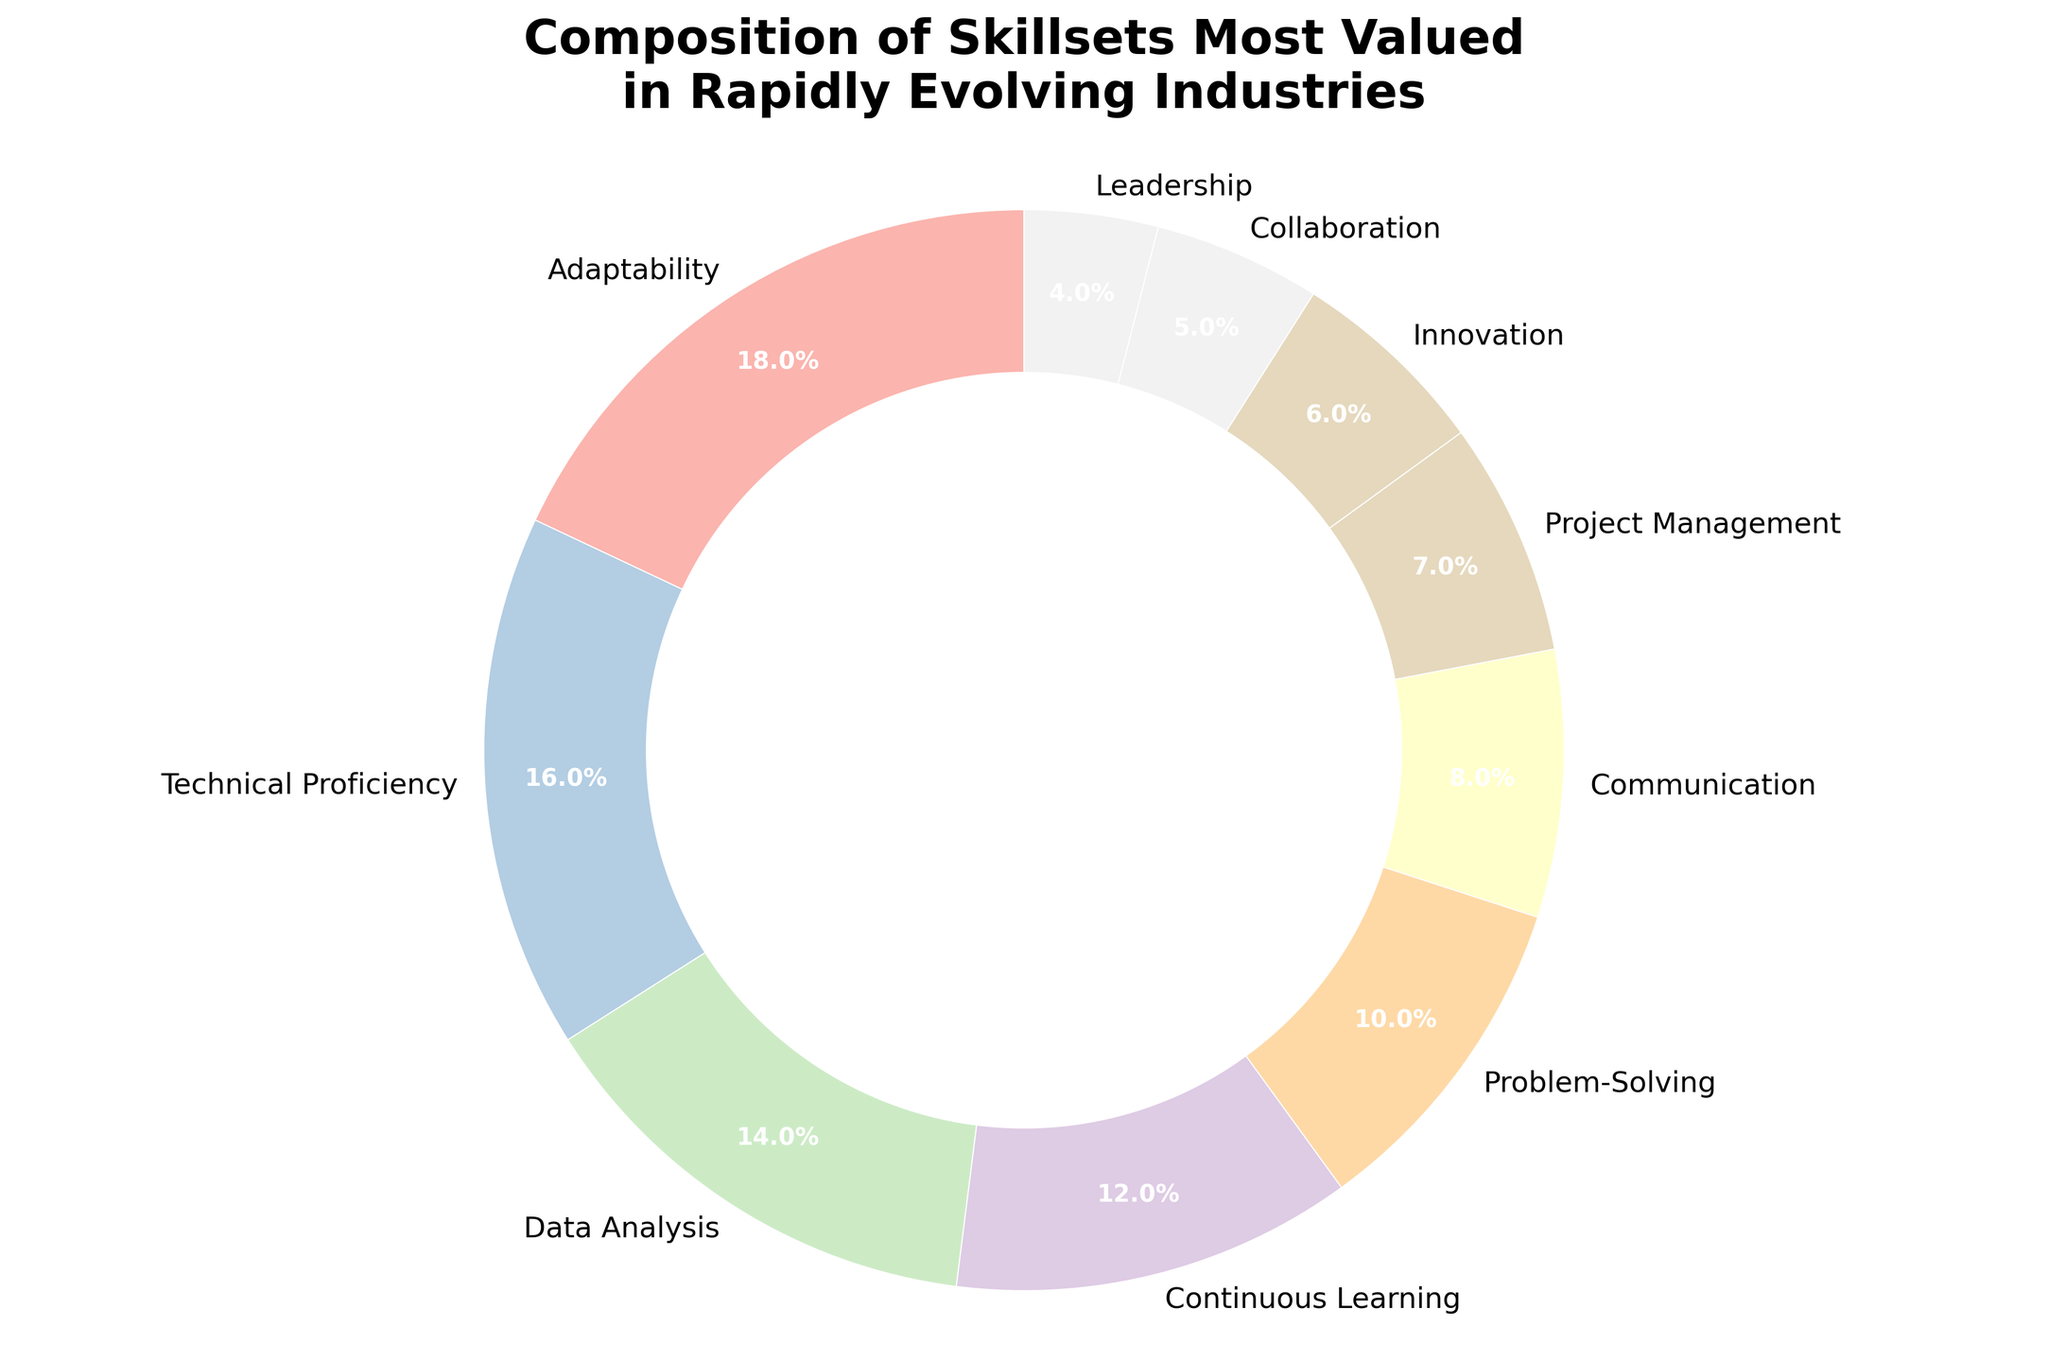What percentage of the skillsets are devoted to data-oriented skills (Data Analysis and Continuous Learning)? Sum the percentages for Data Analysis (14%) and Continuous Learning (12%). 14% + 12% = 26%
Answer: 26% Which skill has the smallest portion in the pie chart? The skill with the smallest percentage in the data is Leadership at 4%.
Answer: Leadership How much larger is the portion for Adaptability compared to Collaboration? Adaptability has 18% and Collaboration has 5%. The difference is 18% - 5% = 13%.
Answer: 13% What is the combined percentage of skills related to interpersonal qualities (Communication and Collaboration)? Communication is 8% and Collaboration is 5%. Sum these percentages: 8% + 5% = 13%.
Answer: 13% Which skill has a larger percentage: Problem-Solving or Innovation, and by how much? Problem-Solving is at 10% and Innovation is at 6%. Problem-Solving is larger by 10% - 6% = 4%.
Answer: Problem-Solving, 4% What is the median percentage value among all skillsets? Arrange the percentages in ascending order: 4, 5, 6, 7, 8, 10, 12, 14, 16, 18. The middle two values are 10 and 12, so the median is (10 + 12) / 2 = 11.
Answer: 11 How does the percentage of Project Management compare visually to Technical Proficiency? Project Management's slice is noticeably smaller than Technical Proficiency's slice. Technical Proficiency has 16% and Project Management has 7%.
Answer: Technical Proficiency is larger Which segments in the pie chart are adjacent to continuous learning's segment? Visually inspect the chart to identify that Data Analysis and Problem-Solving are adjacent to Continuous Learning.
Answer: Data Analysis and Problem-Solving What percentage of the pie chart is represented by the smallest three skillsets combined? The smallest three skillsets are Leadership (4%), Collaboration (5%), and Innovation (6%). Sum these percentages: 4% + 5% + 6% = 15%.
Answer: 15% Are there more skills related to management (Project Management, Leadership) or technical (Technical Proficiency, Data Analysis)? Management-related skills total (7% + 4%) = 11%. Technical skills total (16% + 14%) = 30%. Thus, there are more technical-related skills.
Answer: Technical skills 